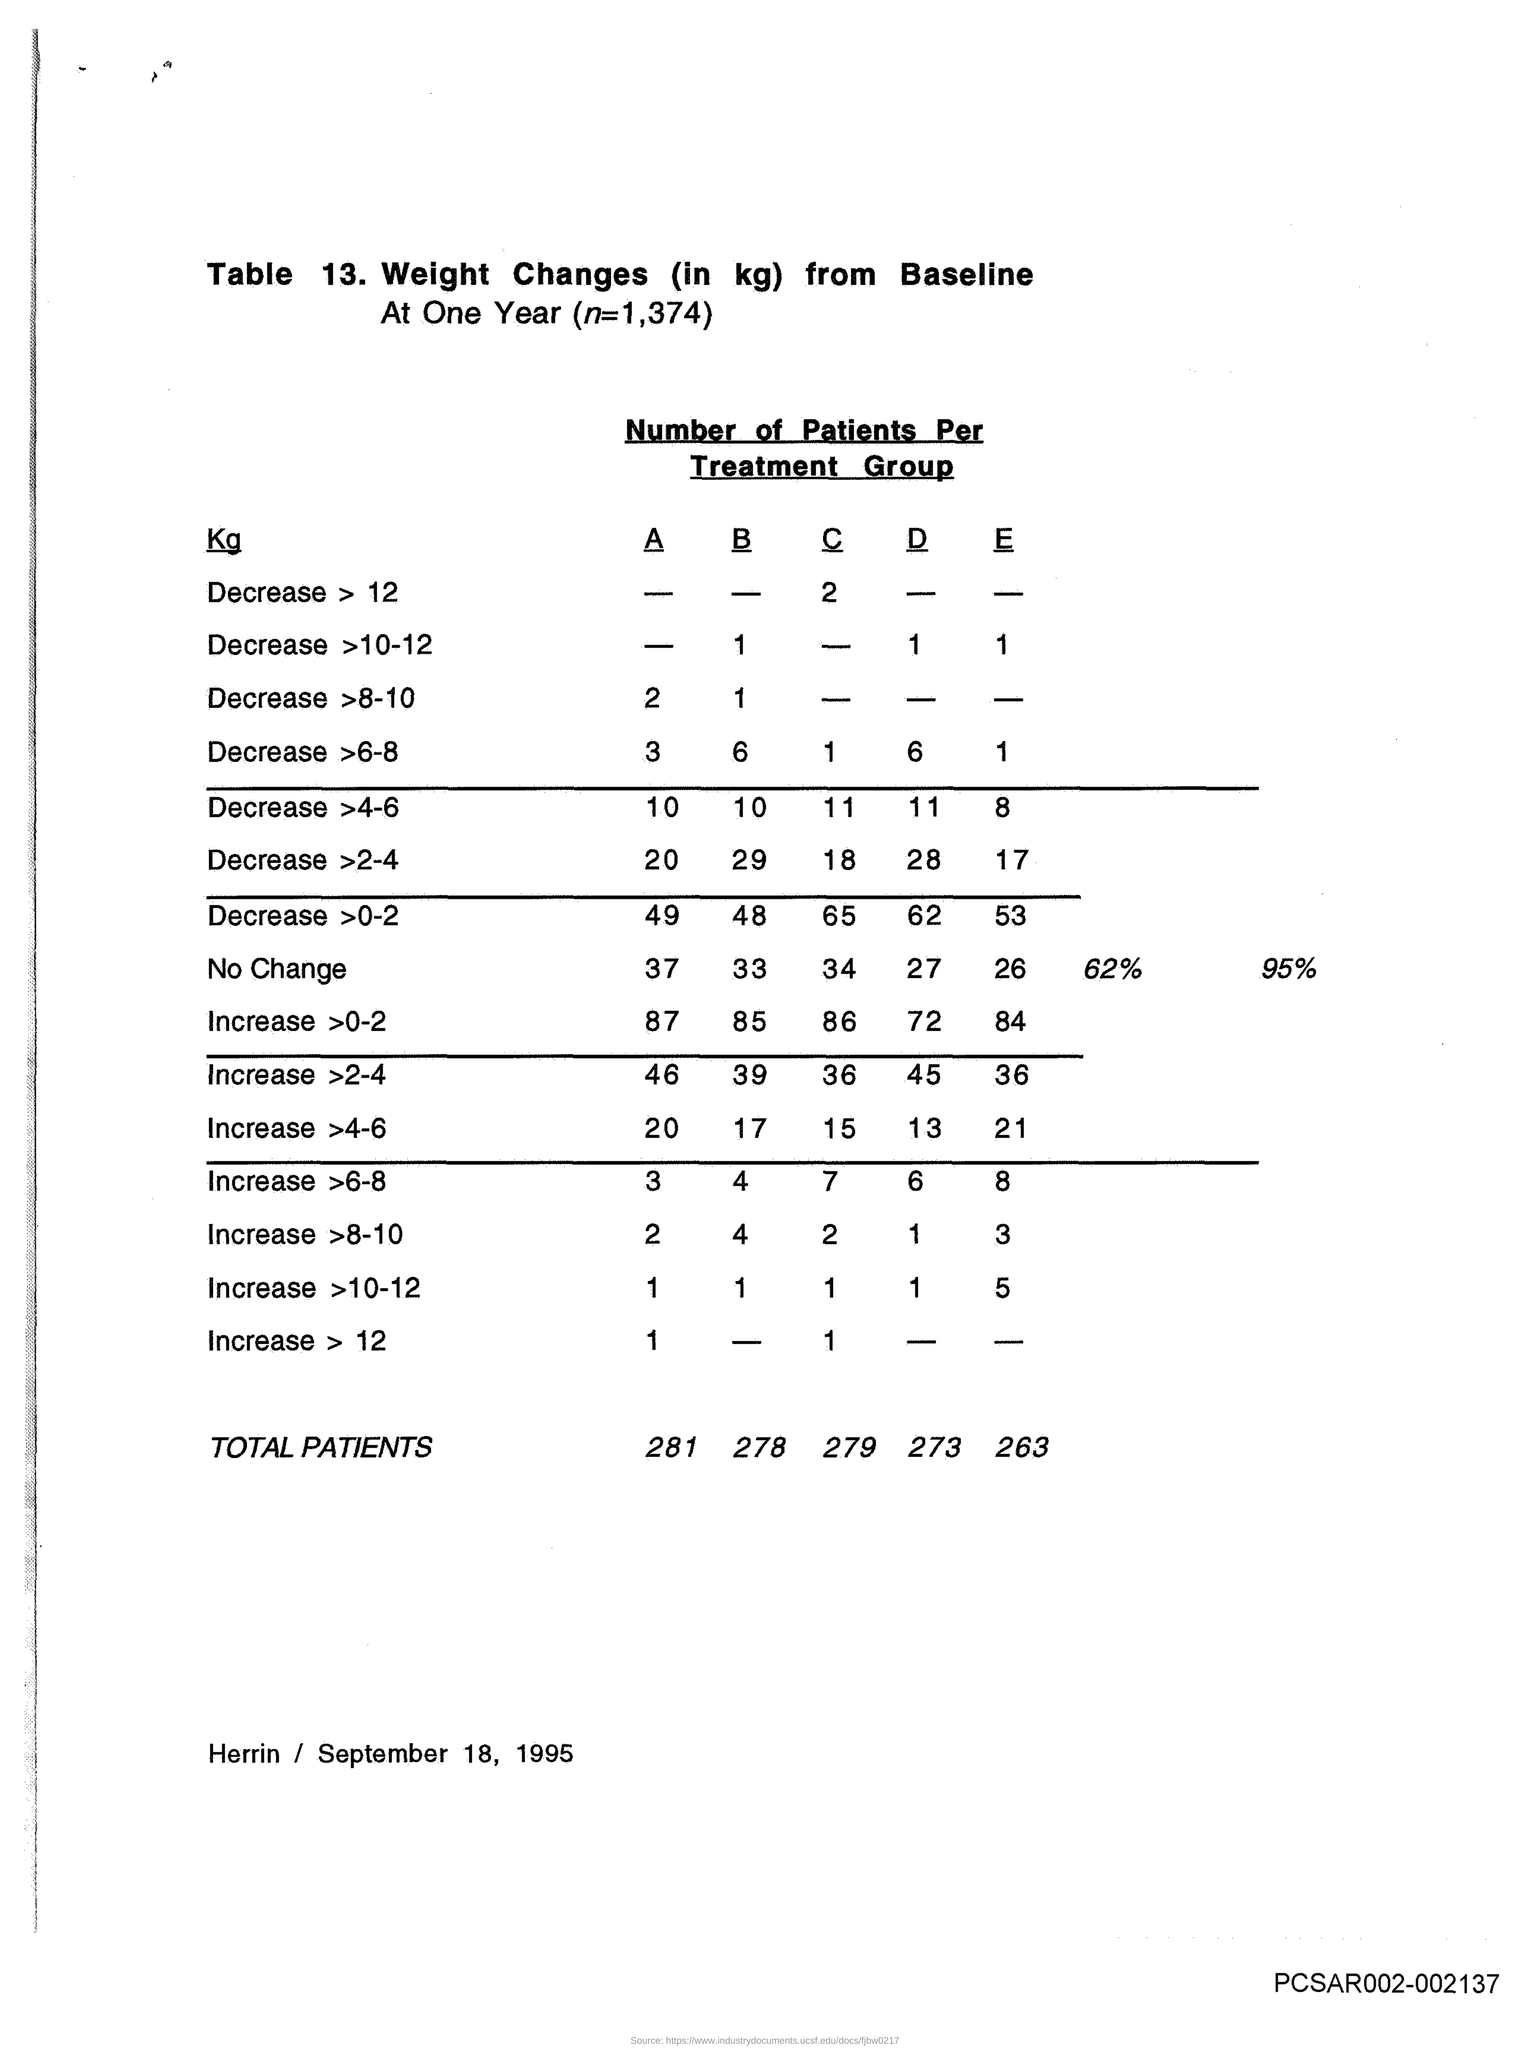What is the table number?
Ensure brevity in your answer.  13. What is the value of n?
Offer a very short reply. 1,374. What is the date mentioned in the document?
Keep it short and to the point. SEPTEMBER 18, 1995. What is the total number of patients in group A?
Provide a succinct answer. 281. What is the total number of patients in group B?
Give a very brief answer. 278. What is the total number of patients in group C ?
Your answer should be compact. 279. 